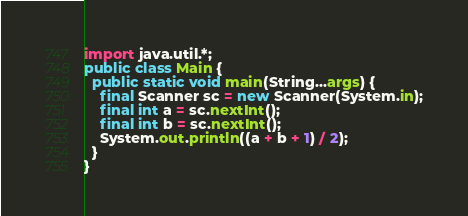<code> <loc_0><loc_0><loc_500><loc_500><_Java_>import java.util.*;
public class Main {
  public static void main(String...args) {
    final Scanner sc = new Scanner(System.in);
    final int a = sc.nextInt();
    final int b = sc.nextInt();
    System.out.println((a + b + 1) / 2);
  }
}</code> 